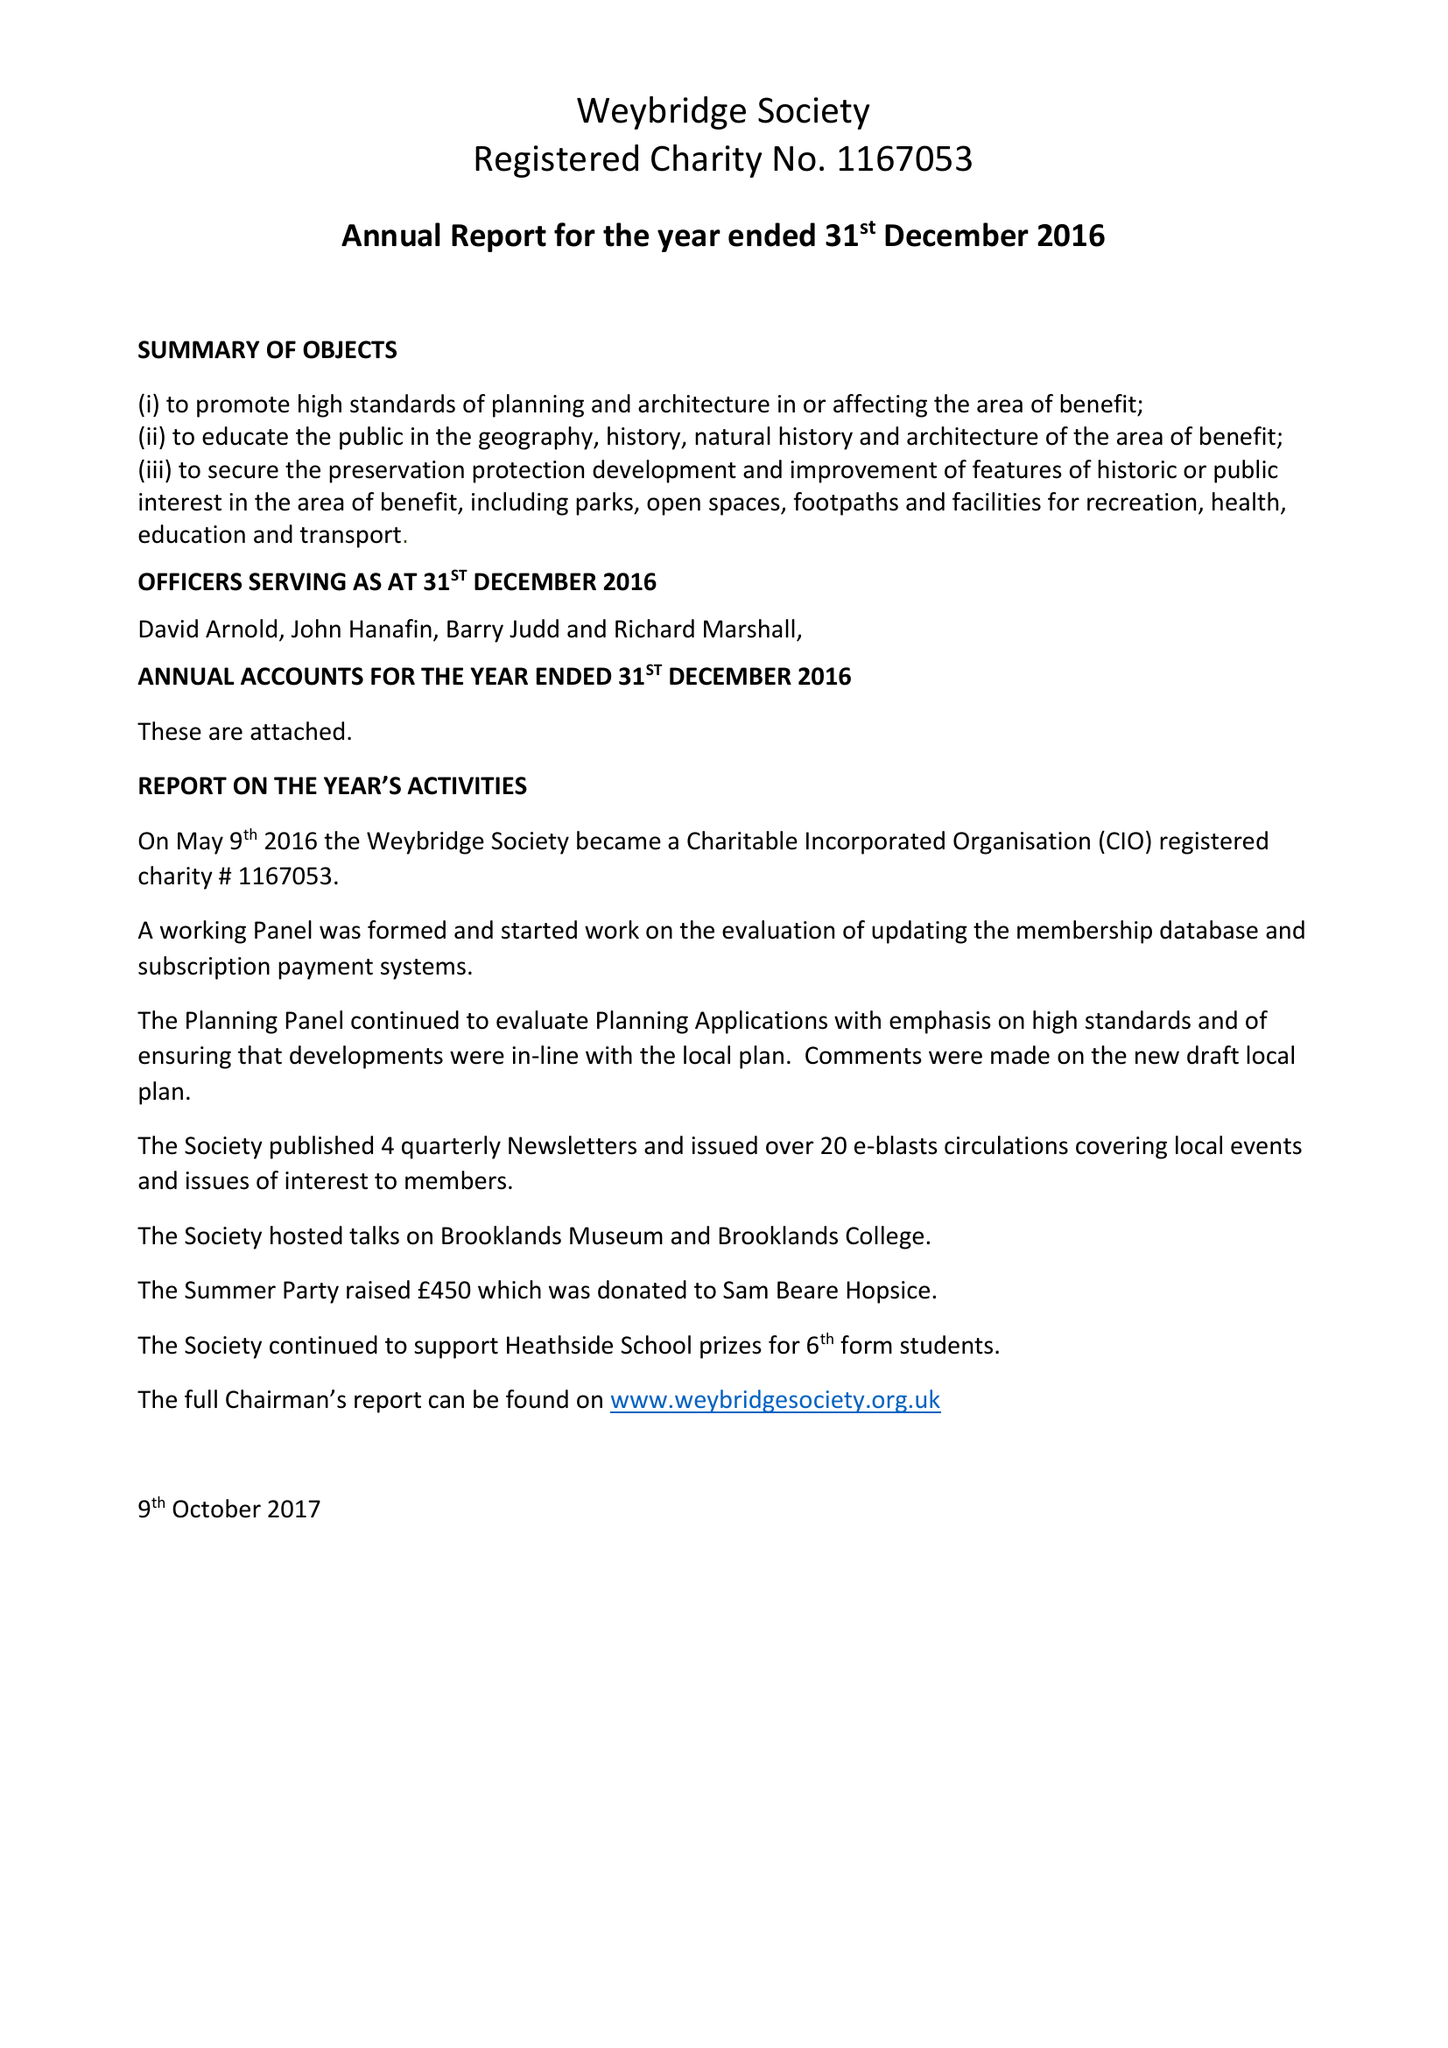What is the value for the charity_number?
Answer the question using a single word or phrase. 1167053 